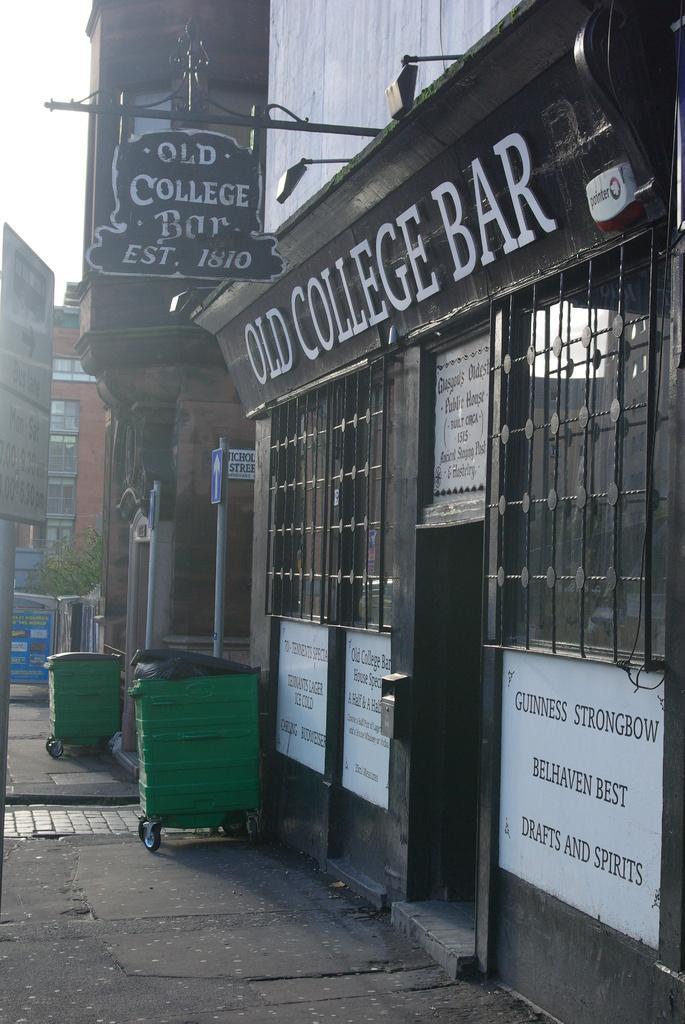Please provide a concise description of this image. In this image, we can see a bar. There are trash bins in the bottom left of the image. There is a building on the left side of the image. There is a board in the top left of the image. 